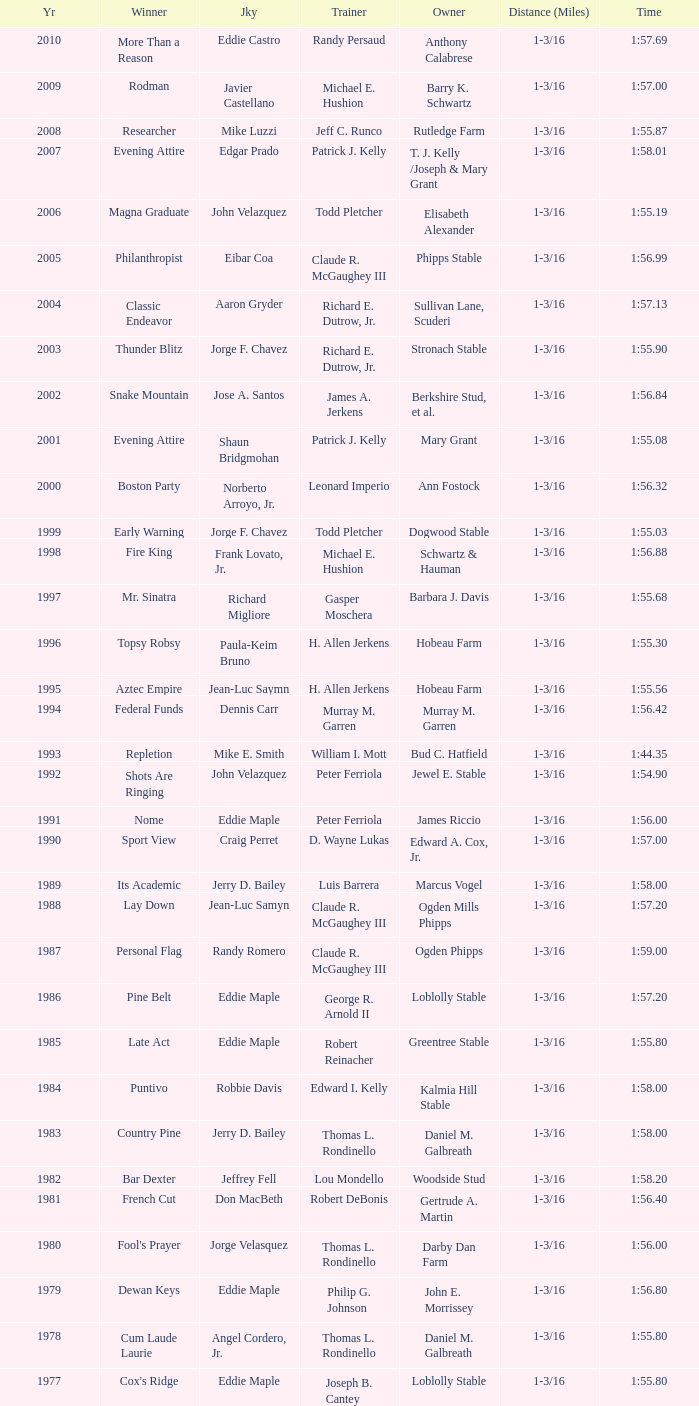Could you parse the entire table as a dict? {'header': ['Yr', 'Winner', 'Jky', 'Trainer', 'Owner', 'Distance (Miles)', 'Time'], 'rows': [['2010', 'More Than a Reason', 'Eddie Castro', 'Randy Persaud', 'Anthony Calabrese', '1-3/16', '1:57.69'], ['2009', 'Rodman', 'Javier Castellano', 'Michael E. Hushion', 'Barry K. Schwartz', '1-3/16', '1:57.00'], ['2008', 'Researcher', 'Mike Luzzi', 'Jeff C. Runco', 'Rutledge Farm', '1-3/16', '1:55.87'], ['2007', 'Evening Attire', 'Edgar Prado', 'Patrick J. Kelly', 'T. J. Kelly /Joseph & Mary Grant', '1-3/16', '1:58.01'], ['2006', 'Magna Graduate', 'John Velazquez', 'Todd Pletcher', 'Elisabeth Alexander', '1-3/16', '1:55.19'], ['2005', 'Philanthropist', 'Eibar Coa', 'Claude R. McGaughey III', 'Phipps Stable', '1-3/16', '1:56.99'], ['2004', 'Classic Endeavor', 'Aaron Gryder', 'Richard E. Dutrow, Jr.', 'Sullivan Lane, Scuderi', '1-3/16', '1:57.13'], ['2003', 'Thunder Blitz', 'Jorge F. Chavez', 'Richard E. Dutrow, Jr.', 'Stronach Stable', '1-3/16', '1:55.90'], ['2002', 'Snake Mountain', 'Jose A. Santos', 'James A. Jerkens', 'Berkshire Stud, et al.', '1-3/16', '1:56.84'], ['2001', 'Evening Attire', 'Shaun Bridgmohan', 'Patrick J. Kelly', 'Mary Grant', '1-3/16', '1:55.08'], ['2000', 'Boston Party', 'Norberto Arroyo, Jr.', 'Leonard Imperio', 'Ann Fostock', '1-3/16', '1:56.32'], ['1999', 'Early Warning', 'Jorge F. Chavez', 'Todd Pletcher', 'Dogwood Stable', '1-3/16', '1:55.03'], ['1998', 'Fire King', 'Frank Lovato, Jr.', 'Michael E. Hushion', 'Schwartz & Hauman', '1-3/16', '1:56.88'], ['1997', 'Mr. Sinatra', 'Richard Migliore', 'Gasper Moschera', 'Barbara J. Davis', '1-3/16', '1:55.68'], ['1996', 'Topsy Robsy', 'Paula-Keim Bruno', 'H. Allen Jerkens', 'Hobeau Farm', '1-3/16', '1:55.30'], ['1995', 'Aztec Empire', 'Jean-Luc Saymn', 'H. Allen Jerkens', 'Hobeau Farm', '1-3/16', '1:55.56'], ['1994', 'Federal Funds', 'Dennis Carr', 'Murray M. Garren', 'Murray M. Garren', '1-3/16', '1:56.42'], ['1993', 'Repletion', 'Mike E. Smith', 'William I. Mott', 'Bud C. Hatfield', '1-3/16', '1:44.35'], ['1992', 'Shots Are Ringing', 'John Velazquez', 'Peter Ferriola', 'Jewel E. Stable', '1-3/16', '1:54.90'], ['1991', 'Nome', 'Eddie Maple', 'Peter Ferriola', 'James Riccio', '1-3/16', '1:56.00'], ['1990', 'Sport View', 'Craig Perret', 'D. Wayne Lukas', 'Edward A. Cox, Jr.', '1-3/16', '1:57.00'], ['1989', 'Its Academic', 'Jerry D. Bailey', 'Luis Barrera', 'Marcus Vogel', '1-3/16', '1:58.00'], ['1988', 'Lay Down', 'Jean-Luc Samyn', 'Claude R. McGaughey III', 'Ogden Mills Phipps', '1-3/16', '1:57.20'], ['1987', 'Personal Flag', 'Randy Romero', 'Claude R. McGaughey III', 'Ogden Phipps', '1-3/16', '1:59.00'], ['1986', 'Pine Belt', 'Eddie Maple', 'George R. Arnold II', 'Loblolly Stable', '1-3/16', '1:57.20'], ['1985', 'Late Act', 'Eddie Maple', 'Robert Reinacher', 'Greentree Stable', '1-3/16', '1:55.80'], ['1984', 'Puntivo', 'Robbie Davis', 'Edward I. Kelly', 'Kalmia Hill Stable', '1-3/16', '1:58.00'], ['1983', 'Country Pine', 'Jerry D. Bailey', 'Thomas L. Rondinello', 'Daniel M. Galbreath', '1-3/16', '1:58.00'], ['1982', 'Bar Dexter', 'Jeffrey Fell', 'Lou Mondello', 'Woodside Stud', '1-3/16', '1:58.20'], ['1981', 'French Cut', 'Don MacBeth', 'Robert DeBonis', 'Gertrude A. Martin', '1-3/16', '1:56.40'], ['1980', "Fool's Prayer", 'Jorge Velasquez', 'Thomas L. Rondinello', 'Darby Dan Farm', '1-3/16', '1:56.00'], ['1979', 'Dewan Keys', 'Eddie Maple', 'Philip G. Johnson', 'John E. Morrissey', '1-3/16', '1:56.80'], ['1978', 'Cum Laude Laurie', 'Angel Cordero, Jr.', 'Thomas L. Rondinello', 'Daniel M. Galbreath', '1-3/16', '1:55.80'], ['1977', "Cox's Ridge", 'Eddie Maple', 'Joseph B. Cantey', 'Loblolly Stable', '1-3/16', '1:55.80'], ['1976', "It's Freezing", 'Jacinto Vasquez', 'Anthony Basile', 'Bwamazon Farm', '1-3/16', '1:56.60'], ['1975', 'Hail The Pirates', 'Ron Turcotte', 'Thomas L. Rondinello', 'Daniel M. Galbreath', '1-3/16', '1:55.60'], ['1974', 'Free Hand', 'Jose Amy', 'Pancho Martin', 'Sigmund Sommer', '1-3/16', '1:55.00'], ['1973', 'True Knight', 'Angel Cordero, Jr.', 'Thomas L. Rondinello', 'Darby Dan Farm', '1-3/16', '1:55.00'], ['1972', 'Sunny And Mild', 'Michael Venezia', 'W. Preston King', 'Harry Rogosin', '1-3/16', '1:54.40'], ['1971', 'Red Reality', 'Jorge Velasquez', 'MacKenzie Miller', 'Cragwood Stables', '1-1/8', '1:49.60'], ['1970', 'Best Turn', 'Larry Adams', 'Reggie Cornell', 'Calumet Farm', '1-1/8', '1:50.00'], ['1969', 'Vif', 'Larry Adams', 'Clarence Meaux', 'Harvey Peltier', '1-1/8', '1:49.20'], ['1968', 'Irish Dude', 'Sandino Hernandez', 'Jack Bradley', 'Richard W. Taylor', '1-1/8', '1:49.60'], ['1967', 'Mr. Right', 'Heliodoro Gustines', 'Evan S. Jackson', 'Mrs. Peter Duchin', '1-1/8', '1:49.60'], ['1966', 'Amberoid', 'Walter Blum', 'Lucien Laurin', 'Reginald N. Webster', '1-1/8', '1:50.60'], ['1965', 'Prairie Schooner', 'Eddie Belmonte', 'James W. Smith', 'High Tide Stable', '1-1/8', '1:50.20'], ['1964', 'Third Martini', 'William Boland', 'H. Allen Jerkens', 'Hobeau Farm', '1-1/8', '1:50.60'], ['1963', 'Uppercut', 'Manuel Ycaza', 'Willard C. Freeman', 'William Harmonay', '1-1/8', '1:35.40'], ['1962', 'Grid Iron Hero', 'Manuel Ycaza', 'Laz Barrera', 'Emil Dolce', '1 mile', '1:34.00'], ['1961', 'Manassa Mauler', 'Braulio Baeza', 'Pancho Martin', 'Emil Dolce', '1 mile', '1:36.20'], ['1960', 'Cranberry Sauce', 'Heliodoro Gustines', 'not found', 'Elmendorf Farm', '1 mile', '1:36.20'], ['1959', 'Whitley', 'Eric Guerin', 'Max Hirsch', 'W. Arnold Hanger', '1 mile', '1:36.40'], ['1958', 'Oh Johnny', 'William Boland', 'Norman R. McLeod', 'Mrs. Wallace Gilroy', '1-1/16', '1:43.40'], ['1957', 'Bold Ruler', 'Eddie Arcaro', 'James E. Fitzsimmons', 'Wheatley Stable', '1-1/16', '1:42.80'], ['1956', 'Blessbull', 'Willie Lester', 'not found', 'Morris Sims', '1-1/16', '1:42.00'], ['1955', 'Fabulist', 'Ted Atkinson', 'William C. Winfrey', 'High Tide Stable', '1-1/16', '1:43.60'], ['1954', 'Find', 'Eric Guerin', 'William C. Winfrey', 'Alfred G. Vanderbilt II', '1-1/16', '1:44.00'], ['1953', 'Flaunt', 'S. Cole', 'Hubert W. Williams', 'Arnold Skjeveland', '1-1/16', '1:44.20'], ['1952', 'County Delight', 'Dave Gorman', 'James E. Ryan', 'Rokeby Stable', '1-1/16', '1:43.60'], ['1951', 'Sheilas Reward', 'Ovie Scurlock', 'Eugene Jacobs', 'Mrs. Louis Lazare', '1-1/16', '1:44.60'], ['1950', 'Three Rings', 'Hedley Woodhouse', 'Willie Knapp', 'Mrs. Evelyn L. Hopkins', '1-1/16', '1:44.60'], ['1949', 'Three Rings', 'Ted Atkinson', 'Willie Knapp', 'Mrs. Evelyn L. Hopkins', '1-1/16', '1:47.40'], ['1948', 'Knockdown', 'Ferrill Zufelt', 'Tom Smith', 'Maine Chance Farm', '1-1/16', '1:44.60'], ['1947', 'Gallorette', 'Job Dean Jessop', 'Edward A. Christmas', 'William L. Brann', '1-1/16', '1:45.40'], ['1946', 'Helioptic', 'Paul Miller', 'not found', 'William Goadby Loew', '1-1/16', '1:43.20'], ['1945', 'Olympic Zenith', 'Conn McCreary', 'Willie Booth', 'William G. Helis', '1-1/16', '1:45.60'], ['1944', 'First Fiddle', 'Johnny Longden', 'Edward Mulrenan', 'Mrs. Edward Mulrenan', '1-1/16', '1:44.20'], ['1943', 'The Rhymer', 'Conn McCreary', 'John M. Gaver, Sr.', 'Greentree Stable', '1-1/16', '1:45.00'], ['1942', 'Waller', 'Billie Thompson', 'A. G. Robertson', 'John C. Clark', '1-1/16', '1:44.00'], ['1941', 'Salford II', 'Don Meade', 'not found', 'Ralph B. Strassburger', '1-1/16', '1:44.20'], ['1940', 'He Did', 'Eddie Arcaro', 'J. Thomas Taylor', 'W. Arnold Hanger', '1-1/16', '1:43.20'], ['1939', 'Lovely Night', 'Johnny Longden', 'Henry McDaniel', 'Mrs. F. Ambrose Clark', '1 mile', '1:36.40'], ['1938', 'War Admiral', 'Charles Kurtsinger', 'George Conway', 'Glen Riddle Farm', '1 mile', '1:36.80'], ['1937', 'Snark', 'Johnny Longden', 'James E. Fitzsimmons', 'Wheatley Stable', '1 mile', '1:37.40'], ['1936', 'Good Gamble', 'Samuel Renick', 'Bud Stotler', 'Alfred G. Vanderbilt II', '1 mile', '1:37.20'], ['1935', 'King Saxon', 'Calvin Rainey', 'Charles Shaw', 'C. H. Knebelkamp', '1 mile', '1:37.20'], ['1934', 'Singing Wood', 'Robert Jones', 'James W. Healy', 'Liz Whitney', '1 mile', '1:38.60'], ['1933', 'Kerry Patch', 'Robert Wholey', 'Joseph A. Notter', 'Lee Rosenberg', '1 mile', '1:38.00'], ['1932', 'Halcyon', 'Hank Mills', 'T. J. Healey', 'C. V. Whitney', '1 mile', '1:38.00'], ['1931', 'Halcyon', 'G. Rose', 'T. J. Healey', 'C. V. Whitney', '1 mile', '1:38.40'], ['1930', 'Kildare', 'John Passero', 'Norman Tallman', 'Newtondale Stable', '1 mile', '1:38.60'], ['1929', 'Comstockery', 'Sidney Hebert', 'Thomas W. Murphy', 'Greentree Stable', '1 mile', '1:39.60'], ['1928', 'Kentucky II', 'George Schreiner', 'Max Hirsch', 'A. Charles Schwartz', '1 mile', '1:38.80'], ['1927', 'Light Carbine', 'James McCoy', 'M. J. Dunlevy', 'I. B. Humphreys', '1 mile', '1:36.80'], ['1926', 'Macaw', 'Linus McAtee', 'James G. Rowe, Sr.', 'Harry Payne Whitney', '1 mile', '1:37.00'], ['1925', 'Mad Play', 'Laverne Fator', 'Sam Hildreth', 'Rancocas Stable', '1 mile', '1:36.60'], ['1924', 'Mad Hatter', 'Earl Sande', 'Sam Hildreth', 'Rancocas Stable', '1 mile', '1:36.60'], ['1923', 'Zev', 'Earl Sande', 'Sam Hildreth', 'Rancocas Stable', '1 mile', '1:37.00'], ['1922', 'Grey Lag', 'Laverne Fator', 'Sam Hildreth', 'Rancocas Stable', '1 mile', '1:38.00'], ['1921', 'John P. Grier', 'Frank Keogh', 'James G. Rowe, Sr.', 'Harry Payne Whitney', '1 mile', '1:36.00'], ['1920', 'Cirrus', 'Lavelle Ensor', 'Sam Hildreth', 'Sam Hildreth', '1 mile', '1:38.00'], ['1919', 'Star Master', 'Merritt Buxton', 'Walter B. Jennings', 'A. Kingsley Macomber', '1 mile', '1:37.60'], ['1918', 'Roamer', 'Lawrence Lyke', 'A. J. Goldsborough', 'Andrew Miller', '1 mile', '1:36.60'], ['1917', 'Old Rosebud', 'Frank Robinson', 'Frank D. Weir', 'F. D. Weir & Hamilton C. Applegate', '1 mile', '1:37.60'], ['1916', 'Short Grass', 'Frank Keogh', 'not found', 'Emil Herz', '1 mile', '1:36.40'], ['1915', 'Roamer', 'James Butwell', 'A. J. Goldsborough', 'Andrew Miller', '1 mile', '1:39.20'], ['1914', 'Flying Fairy', 'Tommy Davies', 'J. Simon Healy', 'Edward B. Cassatt', '1 mile', '1:42.20'], ['1913', 'No Race', 'No Race', 'No Race', 'No Race', '1 mile', 'no race'], ['1912', 'No Race', 'No Race', 'No Race', 'No Race', '1 mile', 'no race'], ['1911', 'No Race', 'No Race', 'No Race', 'No Race', '1 mile', 'no race'], ['1910', 'Arasee', 'Buddy Glass', 'Andrew G. Blakely', 'Samuel Emery', '1 mile', '1:39.80'], ['1909', 'No Race', 'No Race', 'No Race', 'No Race', '1 mile', 'no race'], ['1908', 'Jack Atkin', 'Phil Musgrave', 'Herman R. Brandt', 'Barney Schreiber', '1 mile', '1:39.00'], ['1907', 'W. H. Carey', 'George Mountain', 'James Blute', 'Richard F. Carman', '1 mile', '1:40.00'], ['1906', "Ram's Horn", 'L. Perrine', 'W. S. "Jim" Williams', 'W. S. "Jim" Williams', '1 mile', '1:39.40'], ['1905', 'St. Valentine', 'William Crimmins', 'John Shields', 'Alexander Shields', '1 mile', '1:39.20'], ['1904', 'Rosetint', 'Thomas H. Burns', 'James Boden', 'John Boden', '1 mile', '1:39.20'], ['1903', 'Yellow Tail', 'Willie Shaw', 'H. E. Rowell', 'John Hackett', '1m 70yds', '1:45.20'], ['1902', 'Margravite', 'Otto Wonderly', 'not found', 'Charles Fleischmann Sons', '1m 70 yds', '1:46.00']]} What was the winning time for the winning horse, Kentucky ii? 1:38.80. 